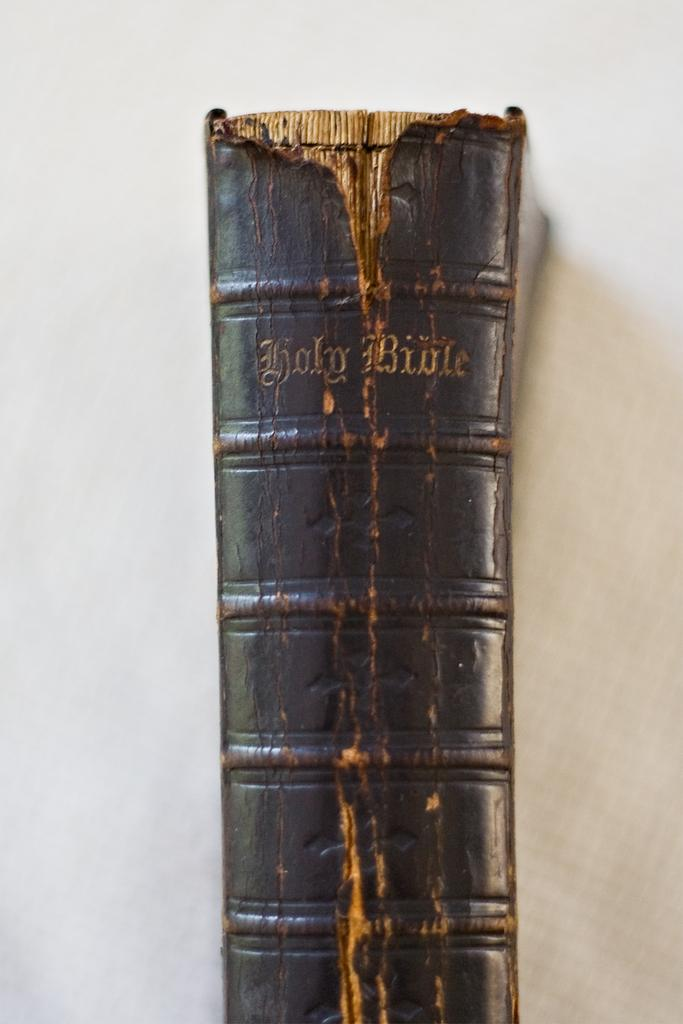What object can be seen in the image? There is a book in the image. What color is the background of the image? The background of the image is white. How many pigs are playing with the book in the image? There are no pigs present in the image; it only features a book against a white background. 